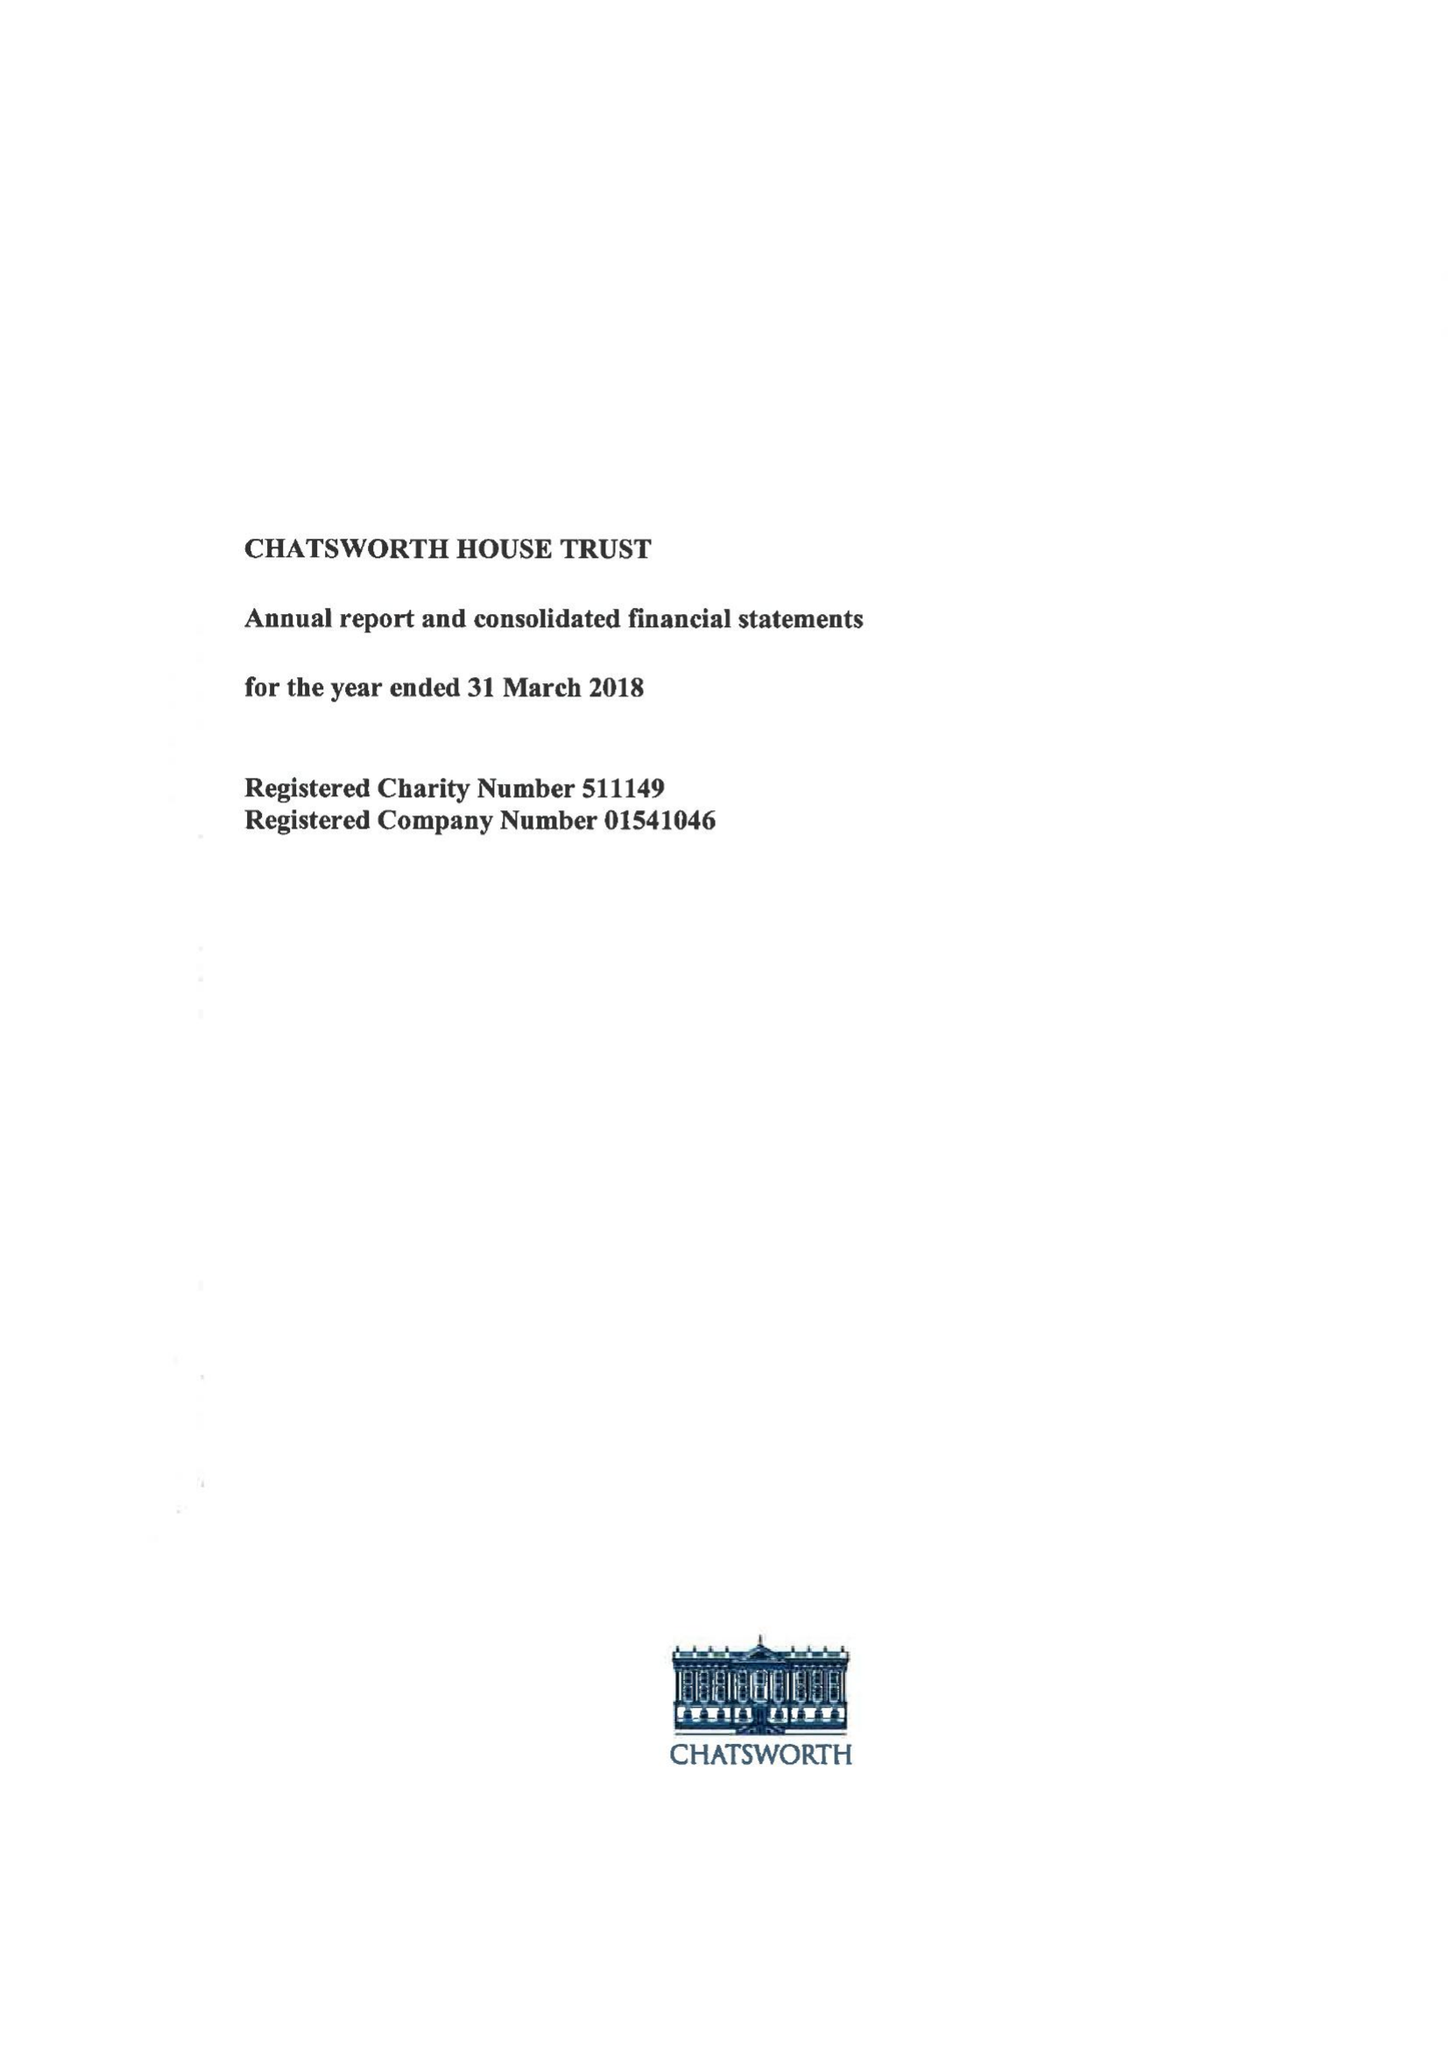What is the value for the address__post_town?
Answer the question using a single word or phrase. BAKEWELL 